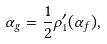Convert formula to latex. <formula><loc_0><loc_0><loc_500><loc_500>\alpha _ { g } = \frac { 1 } { 2 } \rho _ { 1 } ^ { \prime } ( \alpha _ { f } ) ,</formula> 